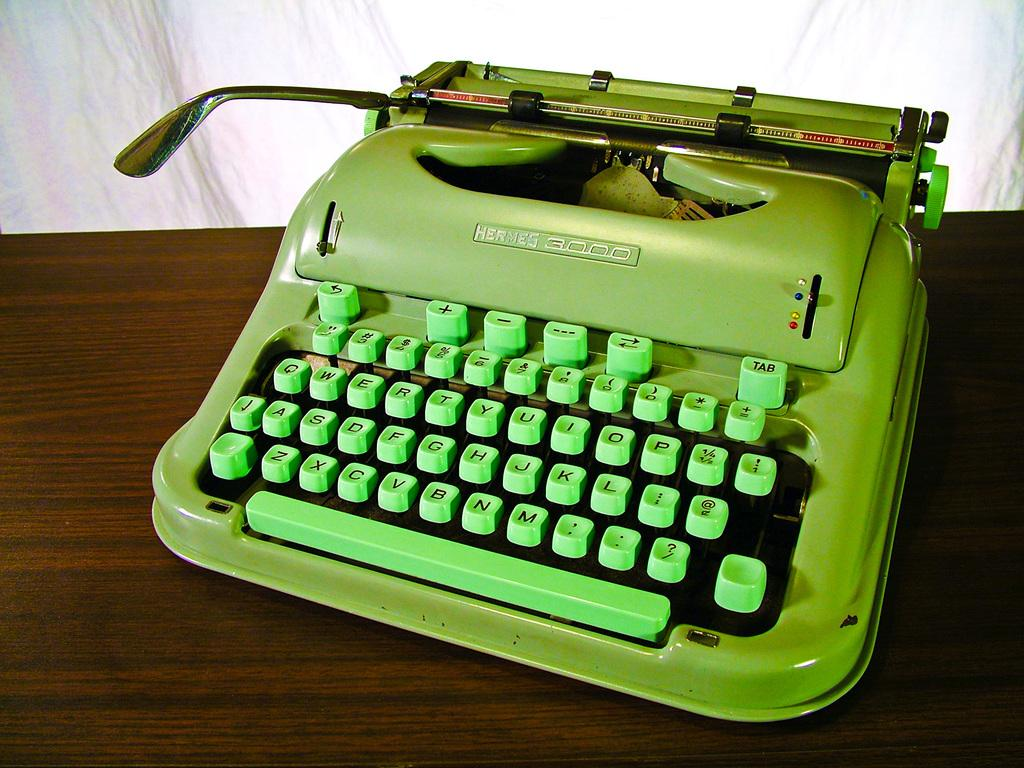<image>
Present a compact description of the photo's key features. A green typewriter with a green qwerty keyboard. 